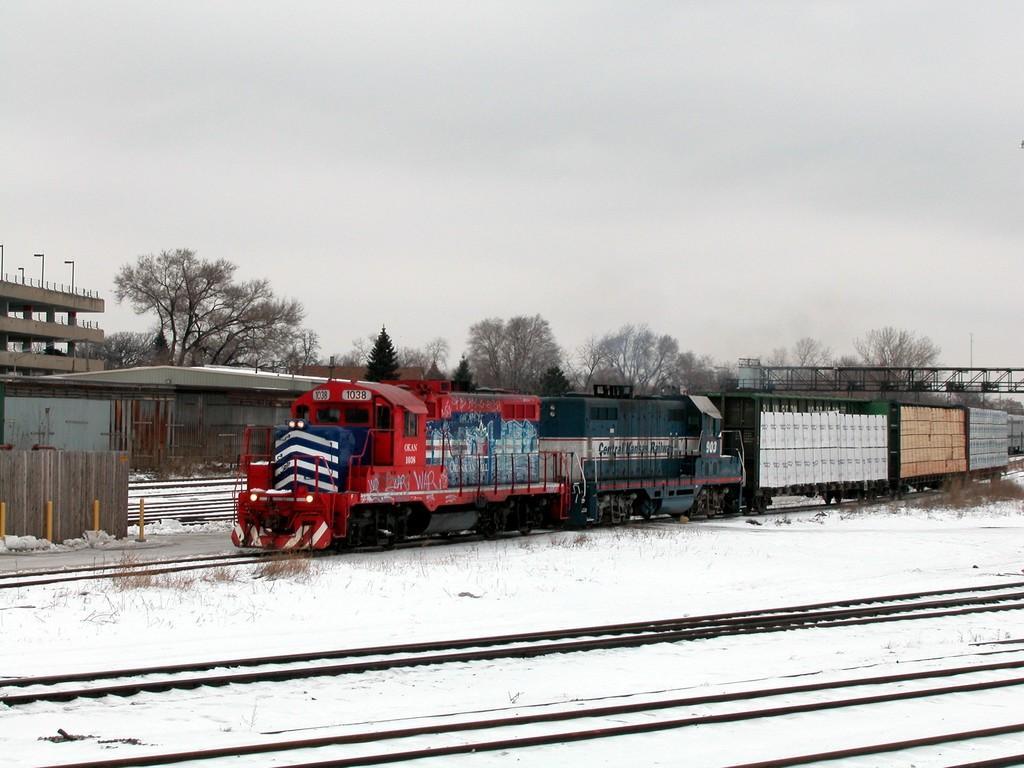In one or two sentences, can you explain what this image depicts? In this image I can see the train on the track. The train is colorful. To the side I can see the snow. In the back I can see the shed, many trees and the sky. 